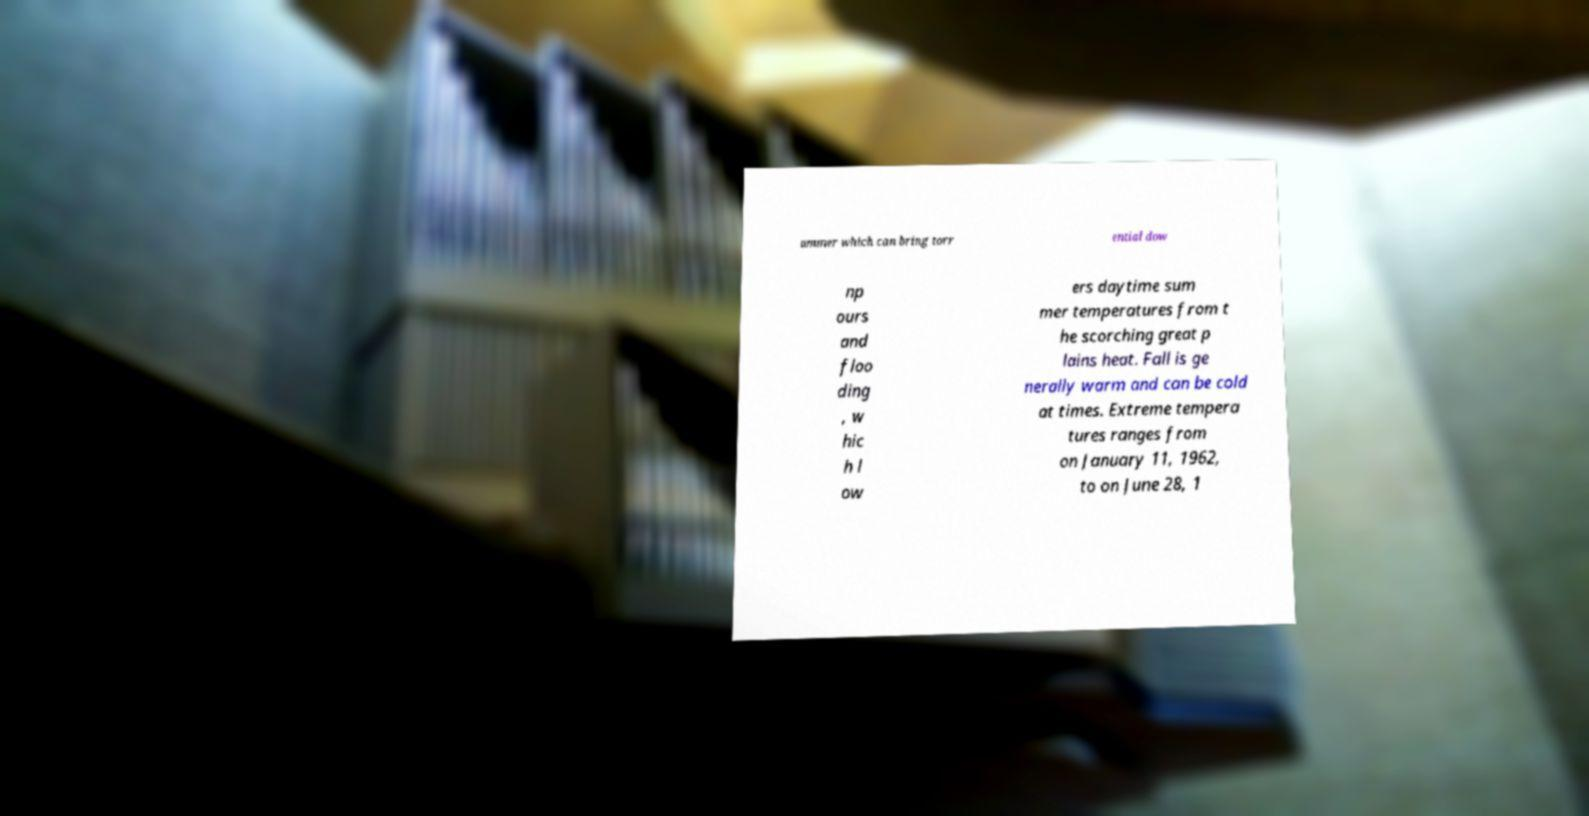For documentation purposes, I need the text within this image transcribed. Could you provide that? ummer which can bring torr ential dow np ours and floo ding , w hic h l ow ers daytime sum mer temperatures from t he scorching great p lains heat. Fall is ge nerally warm and can be cold at times. Extreme tempera tures ranges from on January 11, 1962, to on June 28, 1 